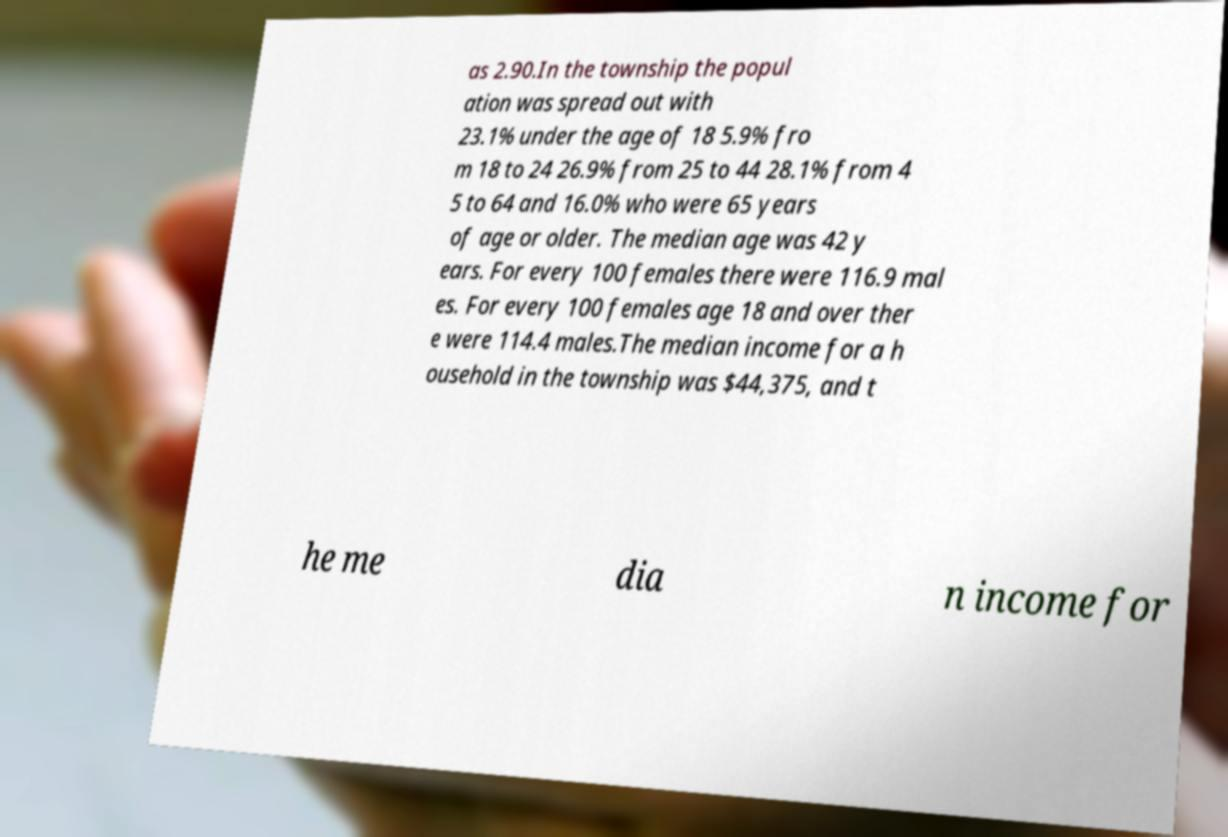Can you read and provide the text displayed in the image?This photo seems to have some interesting text. Can you extract and type it out for me? as 2.90.In the township the popul ation was spread out with 23.1% under the age of 18 5.9% fro m 18 to 24 26.9% from 25 to 44 28.1% from 4 5 to 64 and 16.0% who were 65 years of age or older. The median age was 42 y ears. For every 100 females there were 116.9 mal es. For every 100 females age 18 and over ther e were 114.4 males.The median income for a h ousehold in the township was $44,375, and t he me dia n income for 